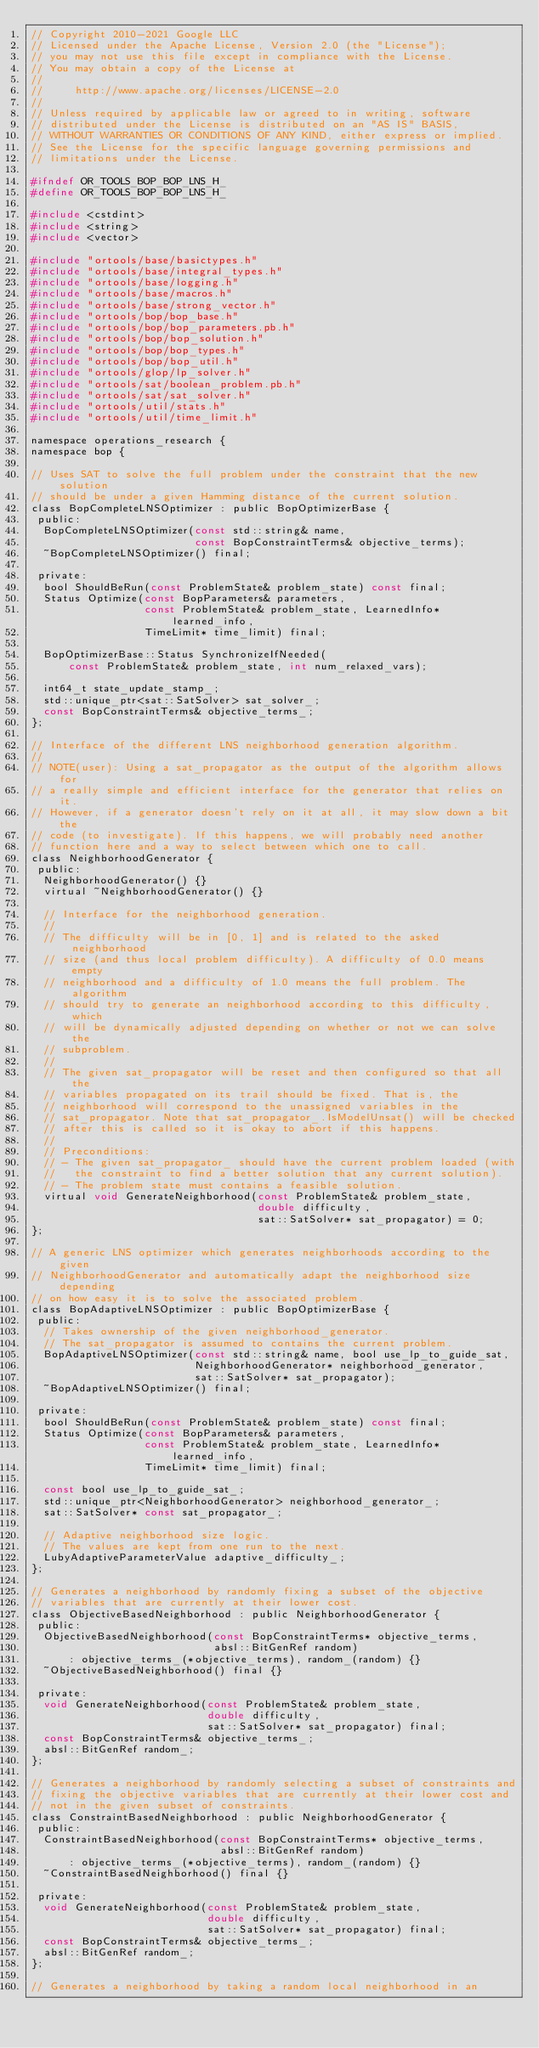Convert code to text. <code><loc_0><loc_0><loc_500><loc_500><_C_>// Copyright 2010-2021 Google LLC
// Licensed under the Apache License, Version 2.0 (the "License");
// you may not use this file except in compliance with the License.
// You may obtain a copy of the License at
//
//     http://www.apache.org/licenses/LICENSE-2.0
//
// Unless required by applicable law or agreed to in writing, software
// distributed under the License is distributed on an "AS IS" BASIS,
// WITHOUT WARRANTIES OR CONDITIONS OF ANY KIND, either express or implied.
// See the License for the specific language governing permissions and
// limitations under the License.

#ifndef OR_TOOLS_BOP_BOP_LNS_H_
#define OR_TOOLS_BOP_BOP_LNS_H_

#include <cstdint>
#include <string>
#include <vector>

#include "ortools/base/basictypes.h"
#include "ortools/base/integral_types.h"
#include "ortools/base/logging.h"
#include "ortools/base/macros.h"
#include "ortools/base/strong_vector.h"
#include "ortools/bop/bop_base.h"
#include "ortools/bop/bop_parameters.pb.h"
#include "ortools/bop/bop_solution.h"
#include "ortools/bop/bop_types.h"
#include "ortools/bop/bop_util.h"
#include "ortools/glop/lp_solver.h"
#include "ortools/sat/boolean_problem.pb.h"
#include "ortools/sat/sat_solver.h"
#include "ortools/util/stats.h"
#include "ortools/util/time_limit.h"

namespace operations_research {
namespace bop {

// Uses SAT to solve the full problem under the constraint that the new solution
// should be under a given Hamming distance of the current solution.
class BopCompleteLNSOptimizer : public BopOptimizerBase {
 public:
  BopCompleteLNSOptimizer(const std::string& name,
                          const BopConstraintTerms& objective_terms);
  ~BopCompleteLNSOptimizer() final;

 private:
  bool ShouldBeRun(const ProblemState& problem_state) const final;
  Status Optimize(const BopParameters& parameters,
                  const ProblemState& problem_state, LearnedInfo* learned_info,
                  TimeLimit* time_limit) final;

  BopOptimizerBase::Status SynchronizeIfNeeded(
      const ProblemState& problem_state, int num_relaxed_vars);

  int64_t state_update_stamp_;
  std::unique_ptr<sat::SatSolver> sat_solver_;
  const BopConstraintTerms& objective_terms_;
};

// Interface of the different LNS neighborhood generation algorithm.
//
// NOTE(user): Using a sat_propagator as the output of the algorithm allows for
// a really simple and efficient interface for the generator that relies on it.
// However, if a generator doesn't rely on it at all, it may slow down a bit the
// code (to investigate). If this happens, we will probably need another
// function here and a way to select between which one to call.
class NeighborhoodGenerator {
 public:
  NeighborhoodGenerator() {}
  virtual ~NeighborhoodGenerator() {}

  // Interface for the neighborhood generation.
  //
  // The difficulty will be in [0, 1] and is related to the asked neighborhood
  // size (and thus local problem difficulty). A difficulty of 0.0 means empty
  // neighborhood and a difficulty of 1.0 means the full problem. The algorithm
  // should try to generate an neighborhood according to this difficulty, which
  // will be dynamically adjusted depending on whether or not we can solve the
  // subproblem.
  //
  // The given sat_propagator will be reset and then configured so that all the
  // variables propagated on its trail should be fixed. That is, the
  // neighborhood will correspond to the unassigned variables in the
  // sat_propagator. Note that sat_propagator_.IsModelUnsat() will be checked
  // after this is called so it is okay to abort if this happens.
  //
  // Preconditions:
  // - The given sat_propagator_ should have the current problem loaded (with
  //   the constraint to find a better solution that any current solution).
  // - The problem state must contains a feasible solution.
  virtual void GenerateNeighborhood(const ProblemState& problem_state,
                                    double difficulty,
                                    sat::SatSolver* sat_propagator) = 0;
};

// A generic LNS optimizer which generates neighborhoods according to the given
// NeighborhoodGenerator and automatically adapt the neighborhood size depending
// on how easy it is to solve the associated problem.
class BopAdaptiveLNSOptimizer : public BopOptimizerBase {
 public:
  // Takes ownership of the given neighborhood_generator.
  // The sat_propagator is assumed to contains the current problem.
  BopAdaptiveLNSOptimizer(const std::string& name, bool use_lp_to_guide_sat,
                          NeighborhoodGenerator* neighborhood_generator,
                          sat::SatSolver* sat_propagator);
  ~BopAdaptiveLNSOptimizer() final;

 private:
  bool ShouldBeRun(const ProblemState& problem_state) const final;
  Status Optimize(const BopParameters& parameters,
                  const ProblemState& problem_state, LearnedInfo* learned_info,
                  TimeLimit* time_limit) final;

  const bool use_lp_to_guide_sat_;
  std::unique_ptr<NeighborhoodGenerator> neighborhood_generator_;
  sat::SatSolver* const sat_propagator_;

  // Adaptive neighborhood size logic.
  // The values are kept from one run to the next.
  LubyAdaptiveParameterValue adaptive_difficulty_;
};

// Generates a neighborhood by randomly fixing a subset of the objective
// variables that are currently at their lower cost.
class ObjectiveBasedNeighborhood : public NeighborhoodGenerator {
 public:
  ObjectiveBasedNeighborhood(const BopConstraintTerms* objective_terms,
                             absl::BitGenRef random)
      : objective_terms_(*objective_terms), random_(random) {}
  ~ObjectiveBasedNeighborhood() final {}

 private:
  void GenerateNeighborhood(const ProblemState& problem_state,
                            double difficulty,
                            sat::SatSolver* sat_propagator) final;
  const BopConstraintTerms& objective_terms_;
  absl::BitGenRef random_;
};

// Generates a neighborhood by randomly selecting a subset of constraints and
// fixing the objective variables that are currently at their lower cost and
// not in the given subset of constraints.
class ConstraintBasedNeighborhood : public NeighborhoodGenerator {
 public:
  ConstraintBasedNeighborhood(const BopConstraintTerms* objective_terms,
                              absl::BitGenRef random)
      : objective_terms_(*objective_terms), random_(random) {}
  ~ConstraintBasedNeighborhood() final {}

 private:
  void GenerateNeighborhood(const ProblemState& problem_state,
                            double difficulty,
                            sat::SatSolver* sat_propagator) final;
  const BopConstraintTerms& objective_terms_;
  absl::BitGenRef random_;
};

// Generates a neighborhood by taking a random local neighborhood in an</code> 